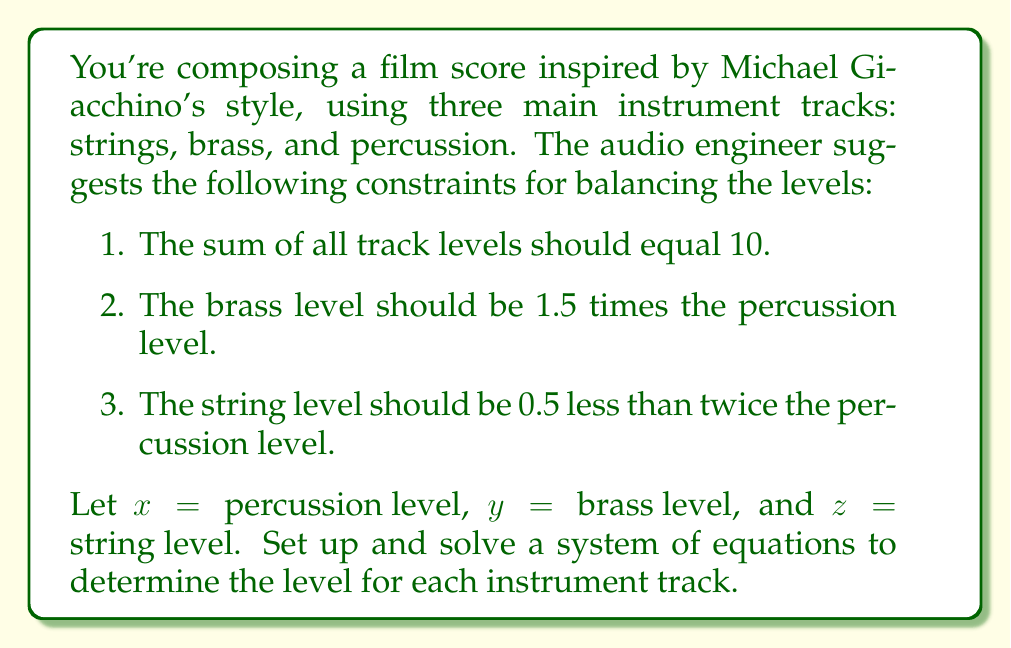What is the answer to this math problem? Let's approach this step-by-step:

1) First, we'll set up our system of equations based on the given constraints:

   $$\begin{cases}
   x + y + z = 10 & \text{(sum of levels)}\\
   y = 1.5x & \text{(brass relation to percussion)}\\
   z = 2x - 0.5 & \text{(string relation to percussion)}
   \end{cases}$$

2) We can substitute the expressions for y and z into the first equation:

   $$x + 1.5x + (2x - 0.5) = 10$$

3) Simplify the left side of the equation:

   $$x + 1.5x + 2x - 0.5 = 10$$
   $$4.5x - 0.5 = 10$$

4) Add 0.5 to both sides:

   $$4.5x = 10.5$$

5) Divide both sides by 4.5:

   $$x = \frac{10.5}{4.5} = \frac{21}{9} = 2.33333...$$

6) Now that we know x (percussion level), we can find y (brass level):

   $$y = 1.5x = 1.5 * \frac{21}{9} = \frac{31.5}{9} = 3.5$$

7) And finally, we can find z (string level):

   $$z = 2x - 0.5 = 2 * \frac{21}{9} - 0.5 = \frac{42}{9} - 0.5 = 4.66666... - 0.5 = 4.16666...$$

Therefore, the levels for each instrument track are:
Percussion (x): 2.33333...
Brass (y): 3.5
Strings (z): 4.16666...
Answer: Percussion: 2.33, Brass: 3.5, Strings: 4.17 